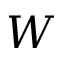Convert formula to latex. <formula><loc_0><loc_0><loc_500><loc_500>W</formula> 